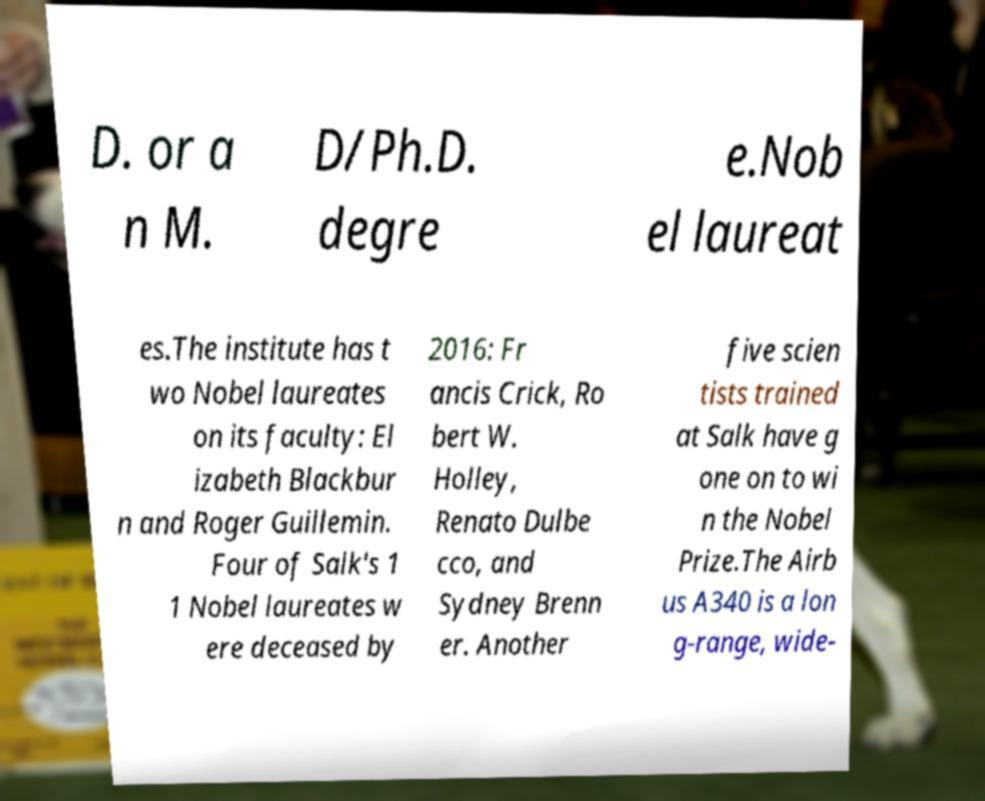What messages or text are displayed in this image? I need them in a readable, typed format. D. or a n M. D/Ph.D. degre e.Nob el laureat es.The institute has t wo Nobel laureates on its faculty: El izabeth Blackbur n and Roger Guillemin. Four of Salk's 1 1 Nobel laureates w ere deceased by 2016: Fr ancis Crick, Ro bert W. Holley, Renato Dulbe cco, and Sydney Brenn er. Another five scien tists trained at Salk have g one on to wi n the Nobel Prize.The Airb us A340 is a lon g-range, wide- 